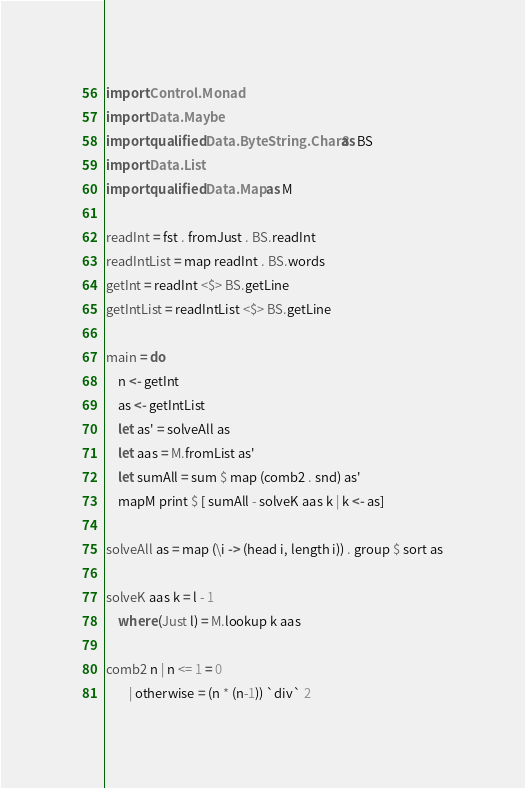<code> <loc_0><loc_0><loc_500><loc_500><_Haskell_>import Control.Monad
import Data.Maybe
import qualified Data.ByteString.Char8 as BS
import Data.List
import qualified Data.Map as M

readInt = fst . fromJust . BS.readInt
readIntList = map readInt . BS.words
getInt = readInt <$> BS.getLine
getIntList = readIntList <$> BS.getLine

main = do
    n <- getInt
    as <- getIntList
    let as' = solveAll as
    let aas = M.fromList as'
    let sumAll = sum $ map (comb2 . snd) as'
    mapM print $ [ sumAll - solveK aas k | k <- as]

solveAll as = map (\i -> (head i, length i)) . group $ sort as

solveK aas k = l - 1
    where (Just l) = M.lookup k aas

comb2 n | n <= 1 = 0
        | otherwise = (n * (n-1)) `div` 2</code> 